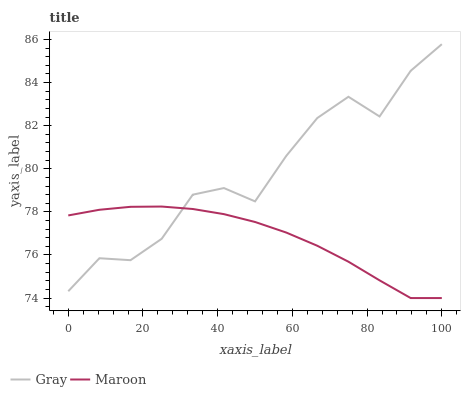Does Maroon have the minimum area under the curve?
Answer yes or no. Yes. Does Gray have the maximum area under the curve?
Answer yes or no. Yes. Does Maroon have the maximum area under the curve?
Answer yes or no. No. Is Maroon the smoothest?
Answer yes or no. Yes. Is Gray the roughest?
Answer yes or no. Yes. Is Maroon the roughest?
Answer yes or no. No. Does Maroon have the lowest value?
Answer yes or no. Yes. Does Gray have the highest value?
Answer yes or no. Yes. Does Maroon have the highest value?
Answer yes or no. No. Does Maroon intersect Gray?
Answer yes or no. Yes. Is Maroon less than Gray?
Answer yes or no. No. Is Maroon greater than Gray?
Answer yes or no. No. 